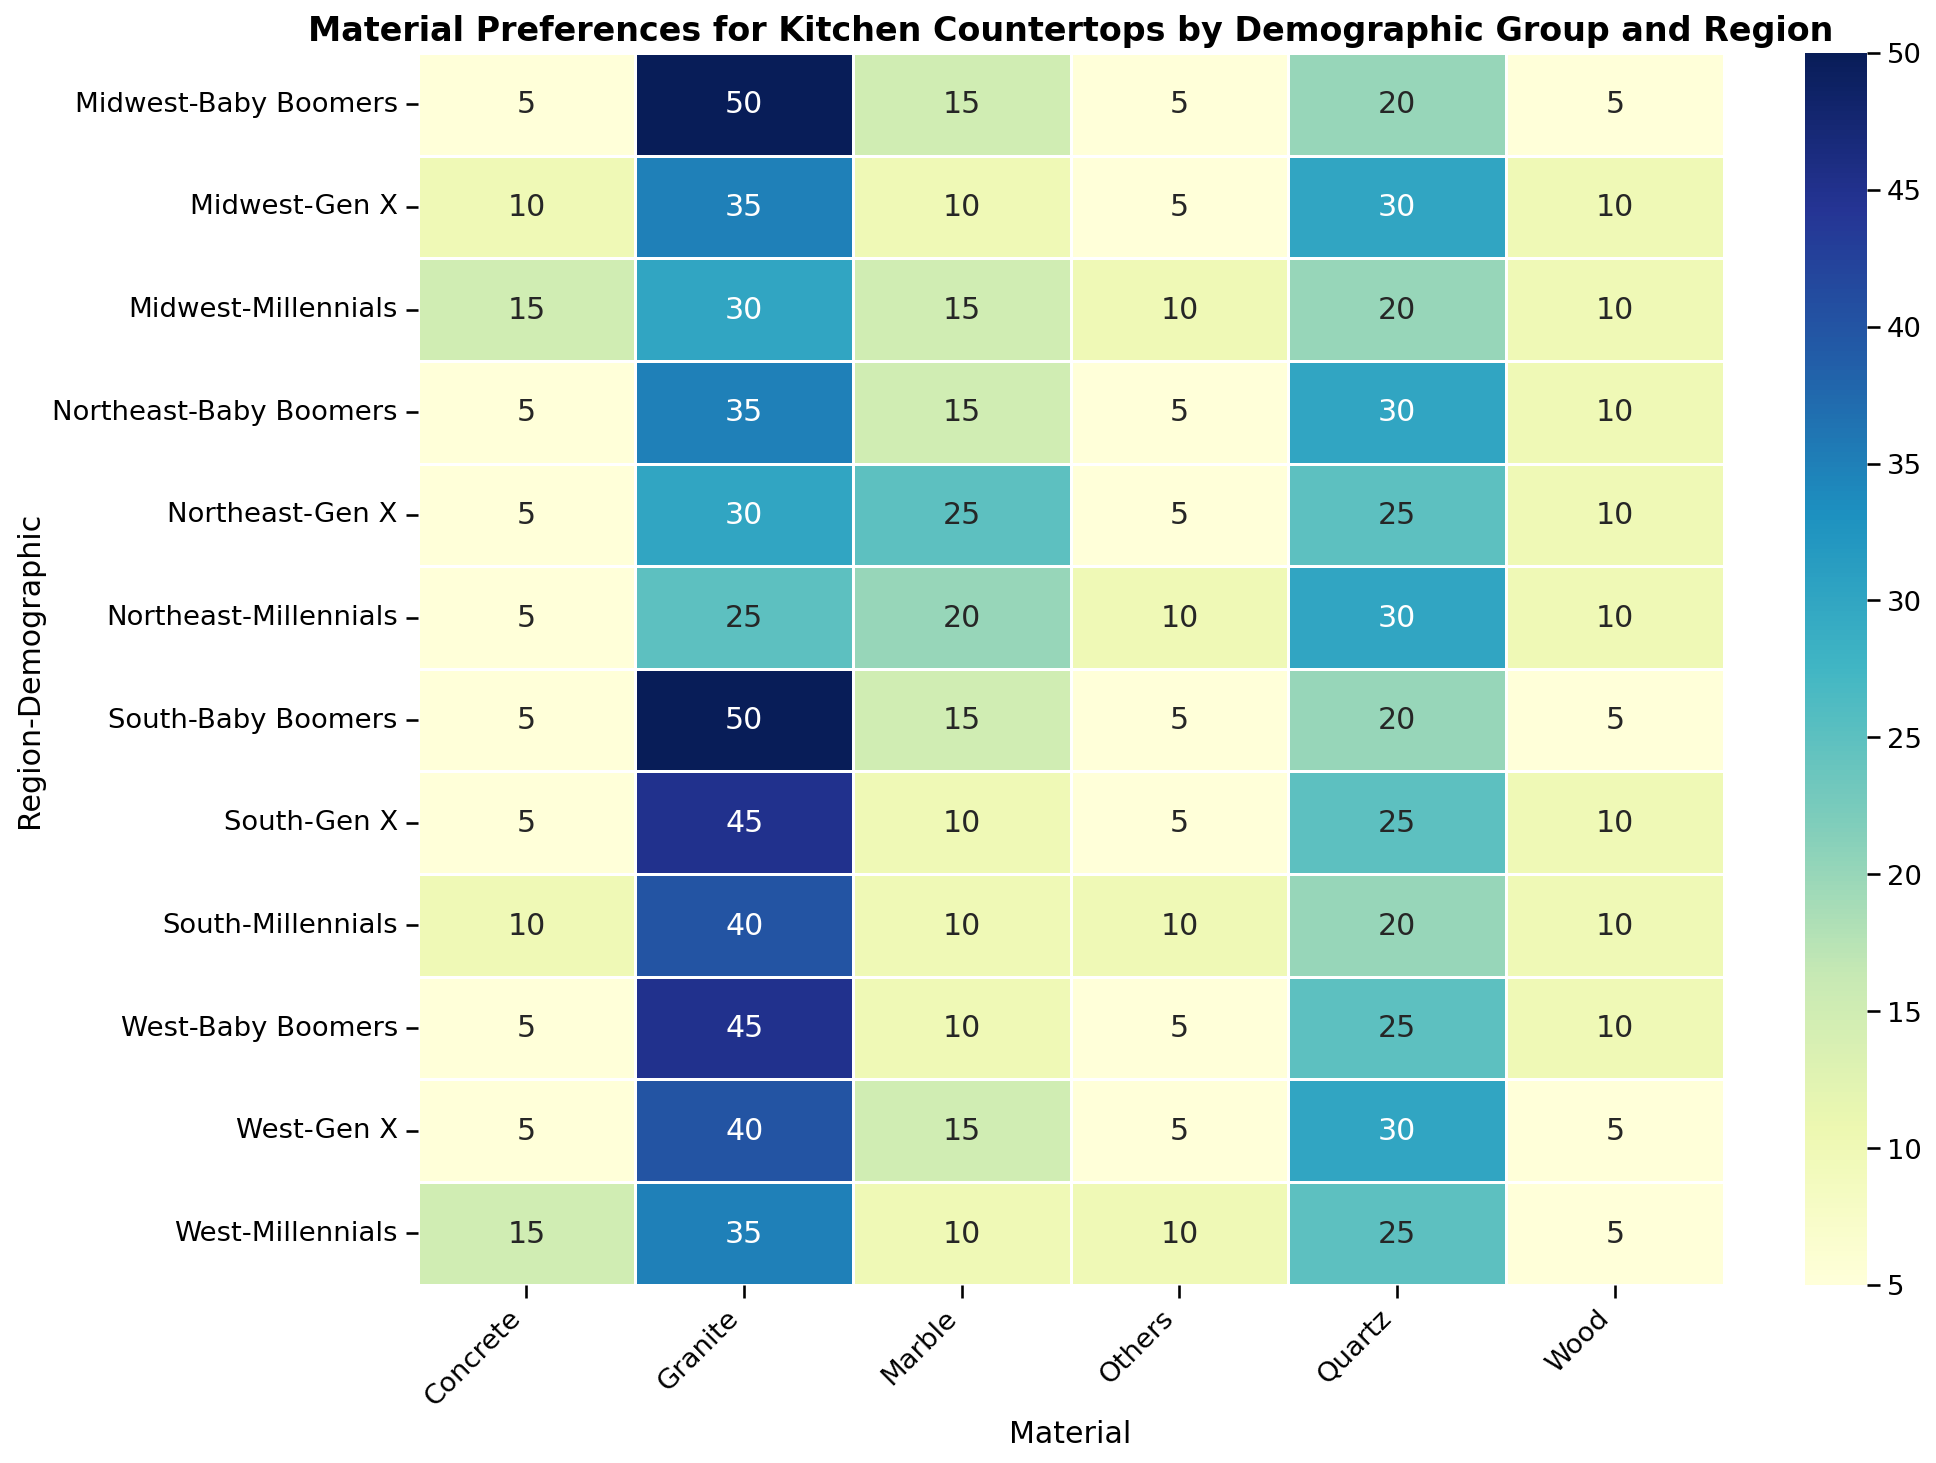Which demographic group in the South has the highest preference for Granite? Find the highest value for Granite in the South region. Baby Boomers in the South have a 50% preference for Granite.
Answer: Baby Boomers What is the combined preference percentage for Quartz and Marble among Millennials in the Midwest? Add the percentages for Quartz (20%) and Marble (15%) for Millennials in the Midwest. 20 + 15 gives 35%.
Answer: 35% Between Gen X in the West and Gen X in the Northeast, which group has a higher preference for Marble? Compare the preference percentages of Marble for Gen X in the West (15%) and Northeast (25%). The Northeast has the higher value.
Answer: Northeast Which material has the least preference among Millennials in the Northeast? Look at the percentage values for all materials for Millennials in the Northeast. The least value is 5% for Concrete.
Answer: Concrete What is the average preference percentage for Wood across all Baby Boomers? Add the percentages for Wood for Baby Boomers in each region and divide by the number of regions. (10% West + 5% Midwest + 10% Northeast + 5% South) / 4 regions = 7.5%.
Answer: 7.5% Is the preference percentage for Concrete higher among Millennials in the Northeast or Gen X in the Midwest? Compare the percentages for Concrete. Millennials in the Northeast have 5%, while Gen X in the Midwest have 10%. The latter is higher.
Answer: Gen X in the Midwest Does the South region show a higher preference for Granite or Quartz among Millennials? Compare the Granite (40%) and Quartz (20%) preference percentages among Millennials in the South.
Answer: Granite Which demographic group in the West has the highest overall preference for Quartz? Find the highest percentage value for Quartz in the West across demographic groups. Gen X has the highest at 30%.
Answer: Gen X What is the difference in preference percentage for Marble between Baby Boomers and Millennials in the Northeast? Subtract the percentage of Marble for Millennials (20%) from Baby Boomers (15%) in the Northeast. The difference is 20 - 15 = 5%.
Answer: 5% What is the total preference percentage for alternative materials (excluding Granite and Quartz) among Millennials in the South? Sum the percentages of Marble (10%), Wood (10%), Concrete (10%), and Others (10%) for Millennials in the South. 10 + 10 + 10 + 10 = 40%.
Answer: 40% 